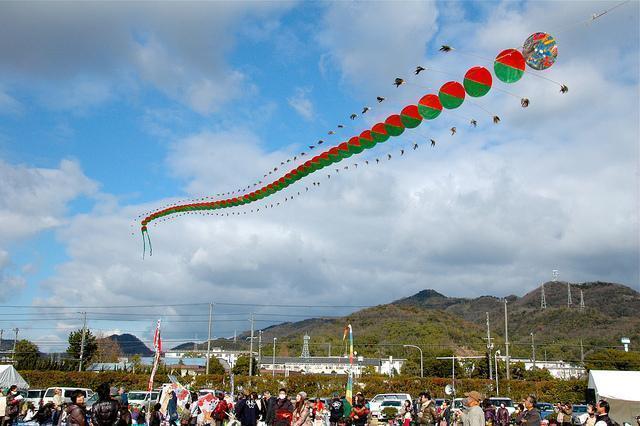Which one of these countries has a flag that is most similar to the kite?
Make your selection and explain in format: 'Answer: answer
Rationale: rationale.'
Options: Canada, bangladesh, peru, lithuania. Answer: bangladesh.
Rationale: The kite is red and green, not yellow, green, and red or red and white. 